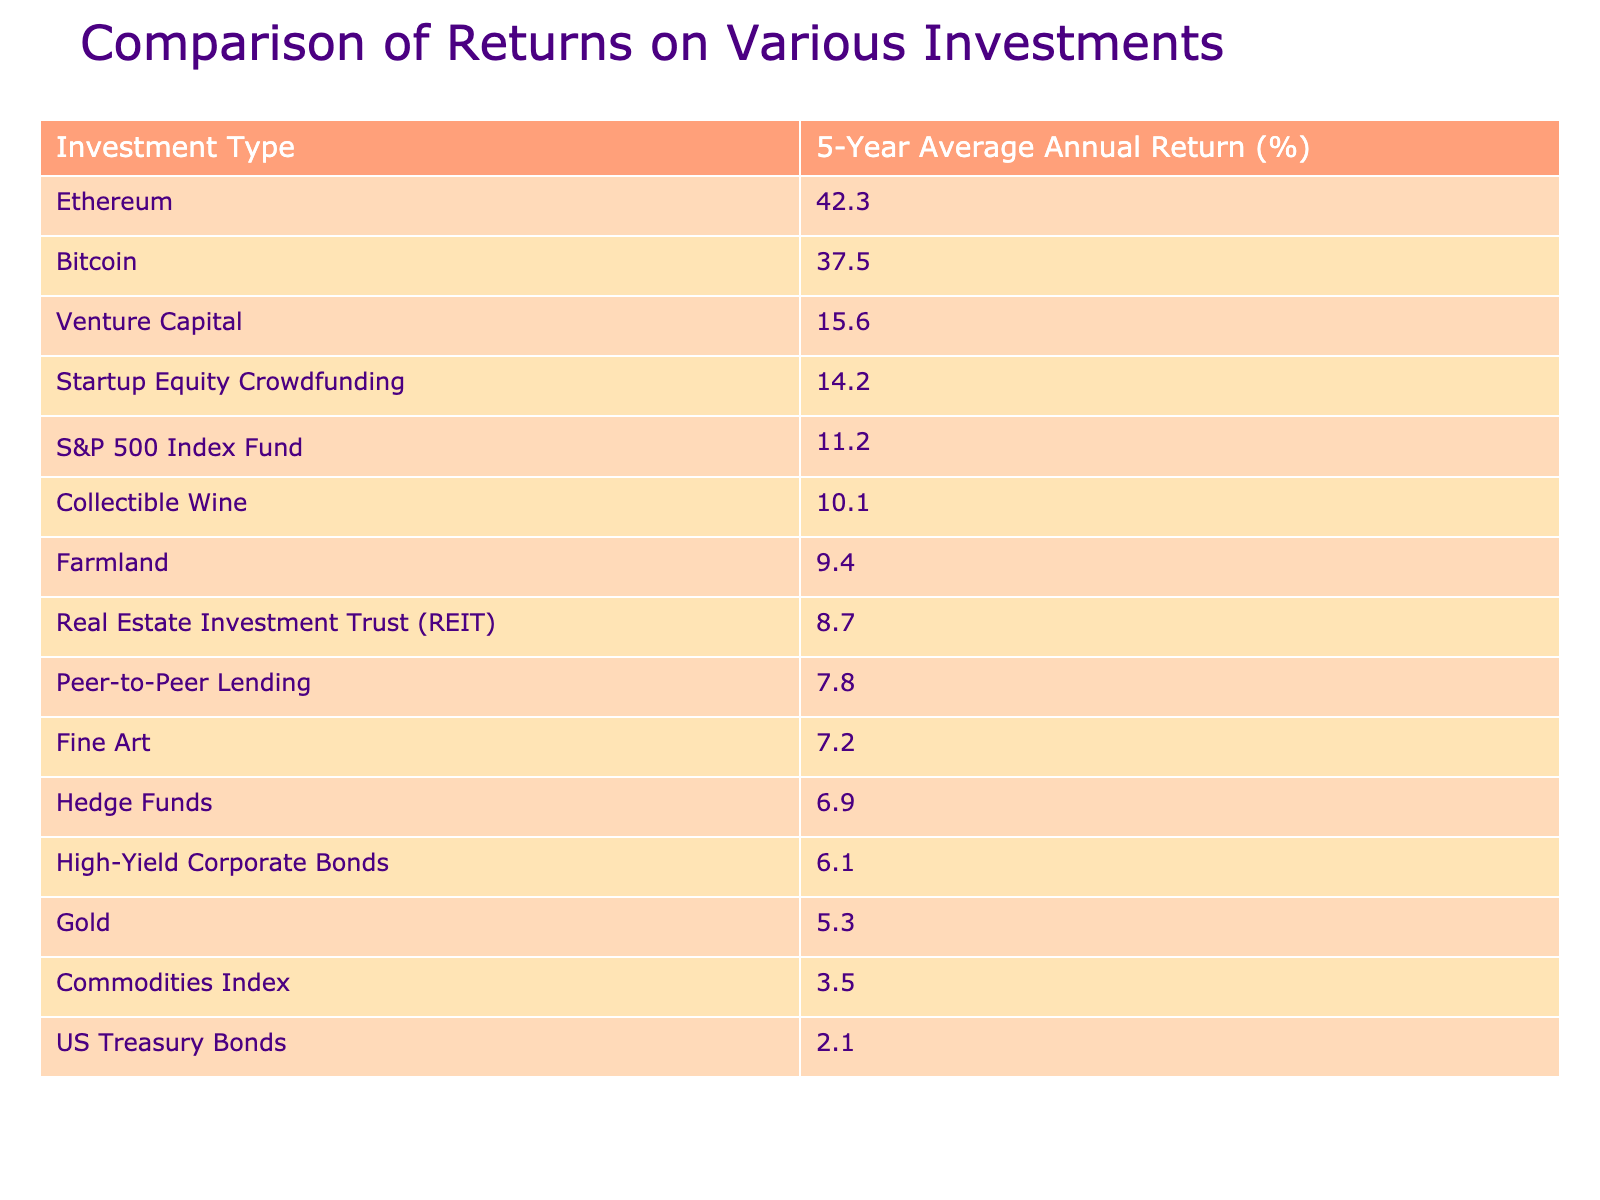What is the highest average annual return among the investments listed? The table indicates that the investment with the highest average annual return is Bitcoin, at 37.5%.
Answer: 37.5% How does Ethereum's average return compare to that of gold? Ethereum has an average return of 42.3%, while gold has a return of 5.3%. This means Ethereum's return is significantly higher.
Answer: 42.3% vs. 5.3% What is the average return of traditional assets from the data provided (S&P 500, US Treasury Bonds, and Gold)? The average return of traditional assets is calculated as (11.2 + 2.1 + 5.3) / 3 = 18.6 / 3 = 6.2%.
Answer: 6.2% Are Venture Capital and Startup Equity Crowdfunding returns above or below 15%? Venture Capital has a return of 15.6% and Startup Equity Crowdfunding has a return of 14.2%, indicating Venture Capital is above and Startup Equity Crowdfunding is below 15%.
Answer: Venture Capital is above 15%, Startup Equity Crowdfunding is below 15% What is the difference in average return between Bitcoin and US Treasury Bonds? Bitcoin's return is 37.5% while US Treasury Bonds' return is 2.1%, so the difference is 37.5 - 2.1 = 35.4%.
Answer: 35.4% Which investment has the lowest average annual return? The investment with the lowest average annual return is US Treasury Bonds, at 2.1%.
Answer: 2.1% If we combine the returns of Gold, High-Yield Corporate Bonds, and Fine Art, what is the total return? The total return for Gold (5.3%), High-Yield Corporate Bonds (6.1%), and Fine Art (7.2%) is 5.3 + 6.1 + 7.2 = 18.6%.
Answer: 18.6% Is the average return of Peer-to-Peer Lending higher or lower than that of Commodities Index? Peer-to-Peer Lending has an average return of 7.8%, while Commodities Index has 3.5%, so Peer-to-Peer Lending is higher than Commodities Index.
Answer: Higher What percentage of the total 5-year average annual returns does the S&P 500 Index Fund represent compared to all investments combined? First, calculate the total return: 11.2 + 37.5 + 8.7 + 5.3 + 6.1 + 7.8 + 15.6 + 7.2 + 42.3 + 2.1 + 3.5 + 6.9 + 14.2 + 9.4 + 10.1 = 223.4%. Then, S&P 500's share is (11.2 / 223.4) * 100 = 5%.
Answer: Approximately 5% What investments fall between a 10% to 20% average annual return range? The investments with returns in this range are Venture Capital (15.6%) and Startup Equity Crowdfunding (14.2%).
Answer: Venture Capital and Startup Equity Crowdfunding 